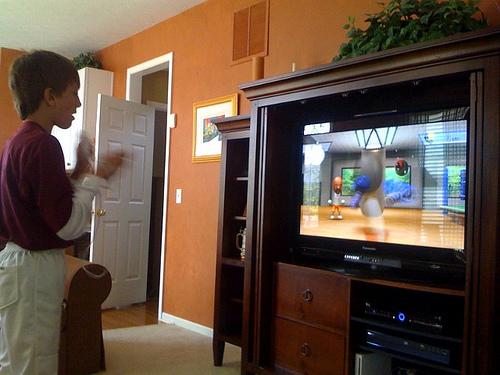What game system are the kids playing with?
Give a very brief answer. Wii. What is the boy playing?
Give a very brief answer. Wii. Why the boy is standing?
Give a very brief answer. Playing game. What color are the walls?
Short answer required. Orange. 